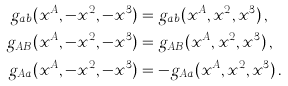<formula> <loc_0><loc_0><loc_500><loc_500>g _ { a b } ( x ^ { A } , - x ^ { 2 } , - x ^ { 3 } ) & = g _ { a b } ( x ^ { A } , x ^ { 2 } , x ^ { 3 } ) \, , \\ g _ { A B } ( x ^ { A } , - x ^ { 2 } , - x ^ { 3 } ) & = g _ { A B } ( x ^ { A } , x ^ { 2 } , x ^ { 3 } ) \, , \\ g _ { A a } ( x ^ { A } , - x ^ { 2 } , - x ^ { 3 } ) & = - g _ { A a } ( x ^ { A } , x ^ { 2 } , x ^ { 3 } ) \, .</formula> 